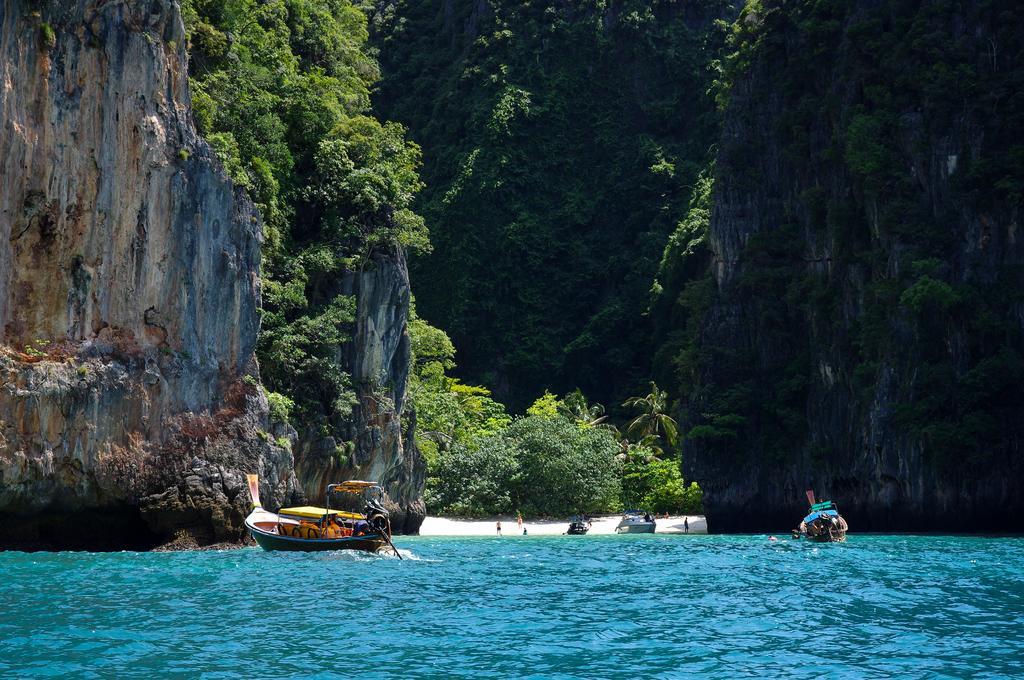Describe this image in one or two sentences. We can see ships on the water and we can see hill,tree,a far we can see boats,persons. 